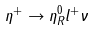<formula> <loc_0><loc_0><loc_500><loc_500>\eta ^ { + } \to \eta ^ { 0 } _ { R } l ^ { + } \nu</formula> 